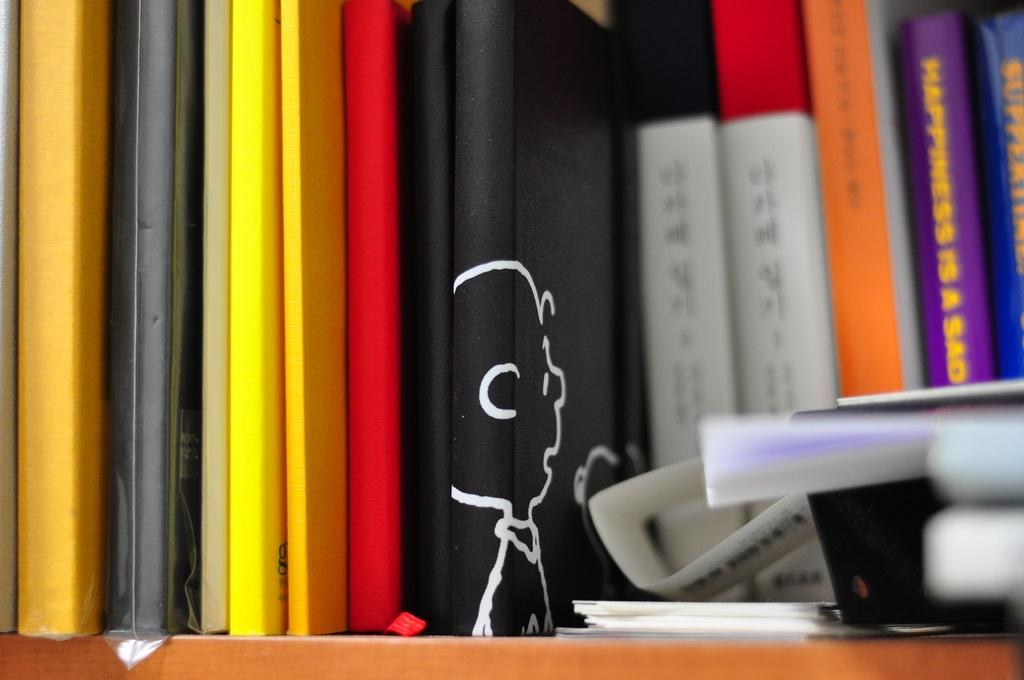<image>
Describe the image concisely. Books in a stack with one that is purple and titled "Happiness is a Sad". 